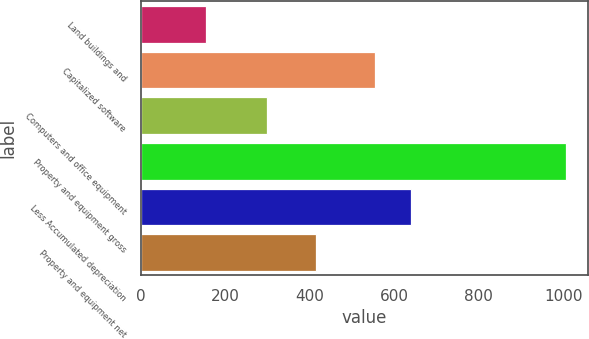<chart> <loc_0><loc_0><loc_500><loc_500><bar_chart><fcel>Land buildings and<fcel>Capitalized software<fcel>Computers and office equipment<fcel>Property and equipment gross<fcel>Less Accumulated depreciation<fcel>Property and equipment net<nl><fcel>155.5<fcel>553.6<fcel>298.6<fcel>1007.7<fcel>638.82<fcel>416.2<nl></chart> 